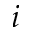<formula> <loc_0><loc_0><loc_500><loc_500>i</formula> 